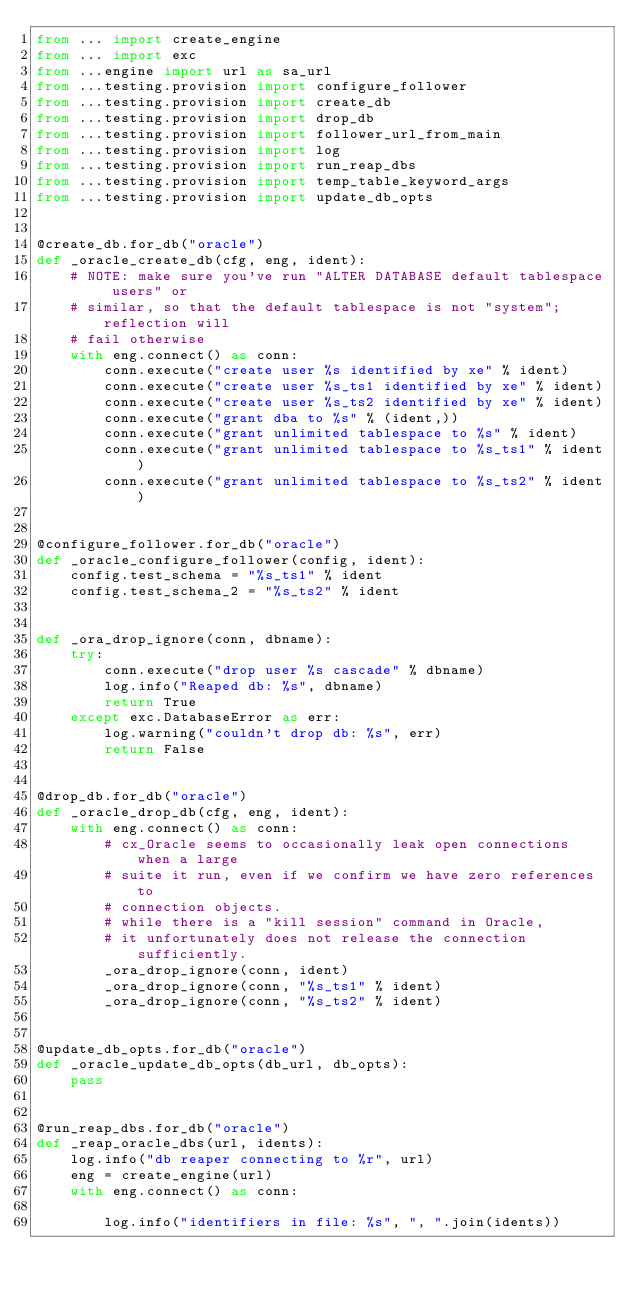Convert code to text. <code><loc_0><loc_0><loc_500><loc_500><_Python_>from ... import create_engine
from ... import exc
from ...engine import url as sa_url
from ...testing.provision import configure_follower
from ...testing.provision import create_db
from ...testing.provision import drop_db
from ...testing.provision import follower_url_from_main
from ...testing.provision import log
from ...testing.provision import run_reap_dbs
from ...testing.provision import temp_table_keyword_args
from ...testing.provision import update_db_opts


@create_db.for_db("oracle")
def _oracle_create_db(cfg, eng, ident):
    # NOTE: make sure you've run "ALTER DATABASE default tablespace users" or
    # similar, so that the default tablespace is not "system"; reflection will
    # fail otherwise
    with eng.connect() as conn:
        conn.execute("create user %s identified by xe" % ident)
        conn.execute("create user %s_ts1 identified by xe" % ident)
        conn.execute("create user %s_ts2 identified by xe" % ident)
        conn.execute("grant dba to %s" % (ident,))
        conn.execute("grant unlimited tablespace to %s" % ident)
        conn.execute("grant unlimited tablespace to %s_ts1" % ident)
        conn.execute("grant unlimited tablespace to %s_ts2" % ident)


@configure_follower.for_db("oracle")
def _oracle_configure_follower(config, ident):
    config.test_schema = "%s_ts1" % ident
    config.test_schema_2 = "%s_ts2" % ident


def _ora_drop_ignore(conn, dbname):
    try:
        conn.execute("drop user %s cascade" % dbname)
        log.info("Reaped db: %s", dbname)
        return True
    except exc.DatabaseError as err:
        log.warning("couldn't drop db: %s", err)
        return False


@drop_db.for_db("oracle")
def _oracle_drop_db(cfg, eng, ident):
    with eng.connect() as conn:
        # cx_Oracle seems to occasionally leak open connections when a large
        # suite it run, even if we confirm we have zero references to
        # connection objects.
        # while there is a "kill session" command in Oracle,
        # it unfortunately does not release the connection sufficiently.
        _ora_drop_ignore(conn, ident)
        _ora_drop_ignore(conn, "%s_ts1" % ident)
        _ora_drop_ignore(conn, "%s_ts2" % ident)


@update_db_opts.for_db("oracle")
def _oracle_update_db_opts(db_url, db_opts):
    pass


@run_reap_dbs.for_db("oracle")
def _reap_oracle_dbs(url, idents):
    log.info("db reaper connecting to %r", url)
    eng = create_engine(url)
    with eng.connect() as conn:

        log.info("identifiers in file: %s", ", ".join(idents))
</code> 